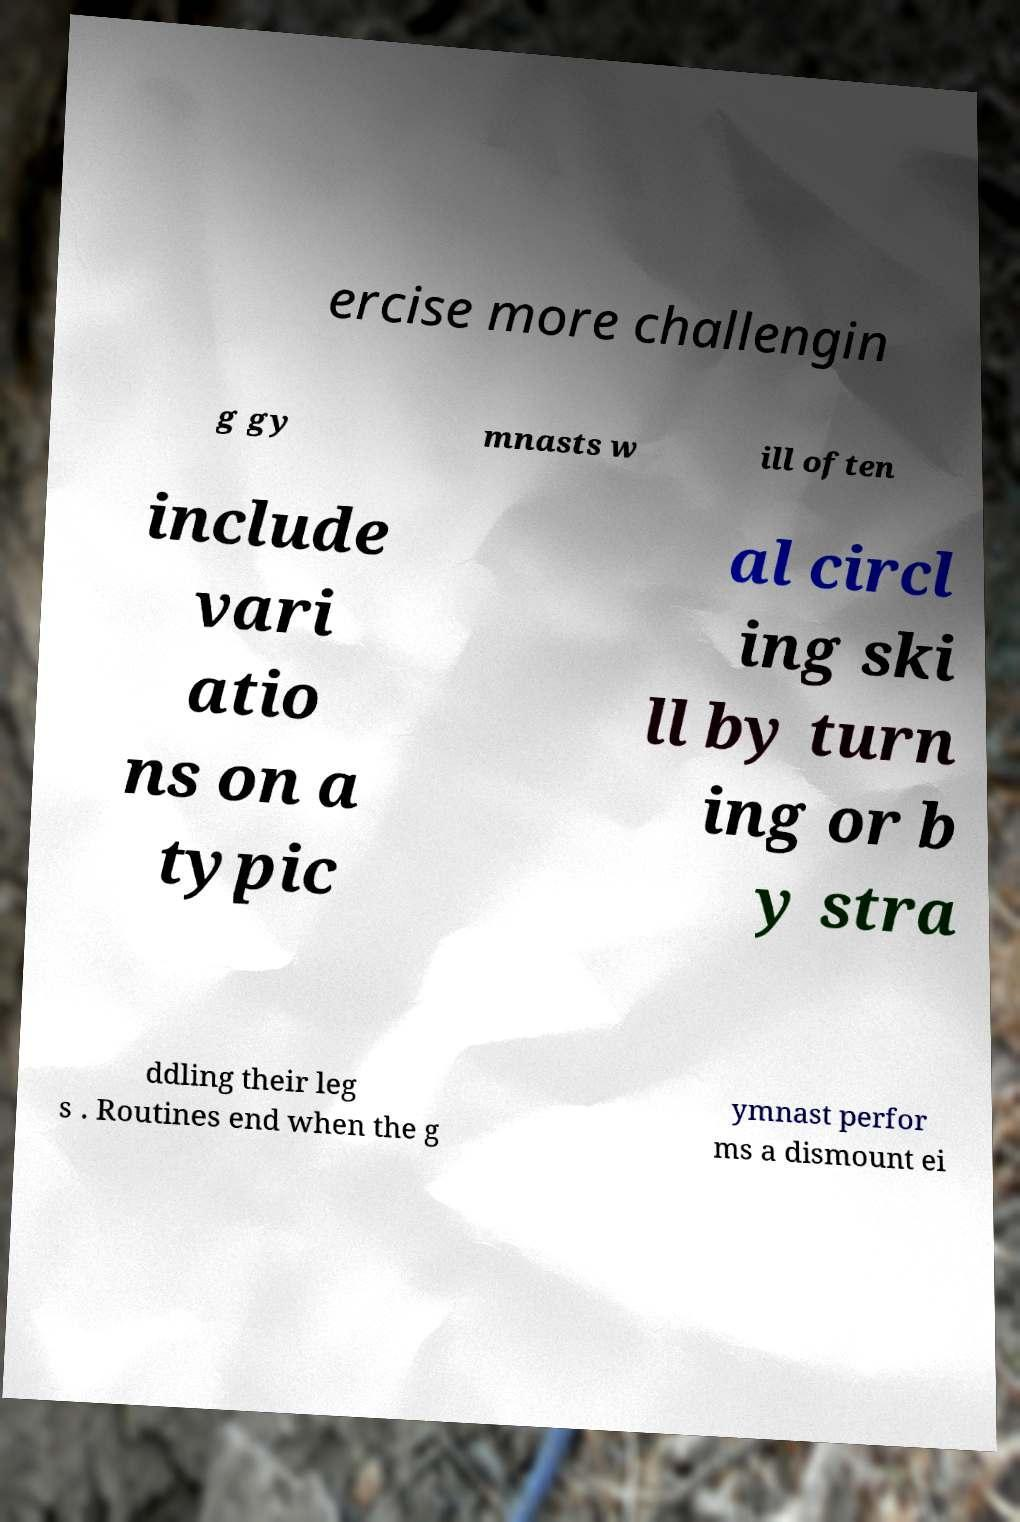What messages or text are displayed in this image? I need them in a readable, typed format. ercise more challengin g gy mnasts w ill often include vari atio ns on a typic al circl ing ski ll by turn ing or b y stra ddling their leg s . Routines end when the g ymnast perfor ms a dismount ei 